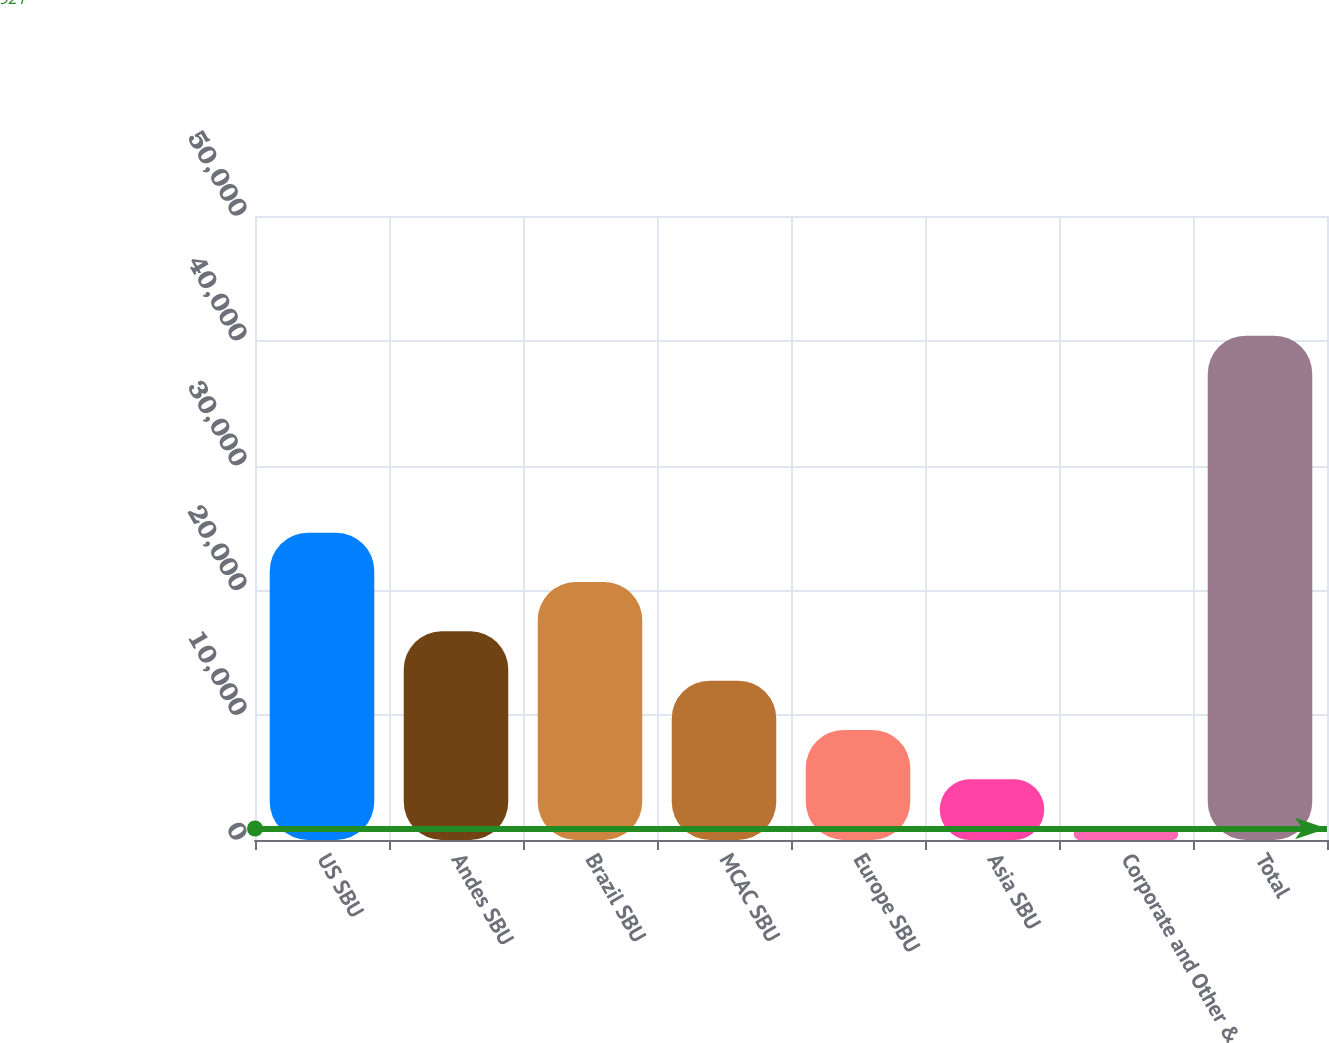Convert chart to OTSL. <chart><loc_0><loc_0><loc_500><loc_500><bar_chart><fcel>US SBU<fcel>Andes SBU<fcel>Brazil SBU<fcel>MCAC SBU<fcel>Europe SBU<fcel>Asia SBU<fcel>Corporate and Other &<fcel>Total<nl><fcel>24615<fcel>16717<fcel>20666<fcel>12768<fcel>8819<fcel>4870<fcel>921<fcel>40411<nl></chart> 